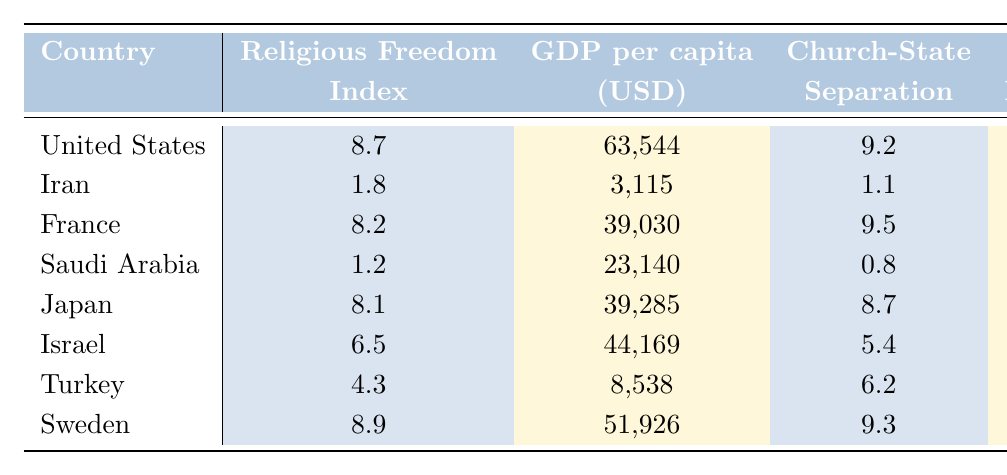What is the Religious Freedom Index of the United States? The Religious Freedom Index for the United States is directly indicated in the table as 8.7.
Answer: 8.7 Which country has the highest GDP per capita? From the GDP per capita column, Sweden has the highest value at 51,926 USD.
Answer: Sweden Is there a significant difference in the Separation of Church and State Score between Iran and Saudi Arabia? The Separation of Church and State Score for Iran is 1.1, while for Saudi Arabia it is 0.8. The difference is 1.1 - 0.8 = 0.3, which is indeed significant considering both are quite low.
Answer: Yes What is the average Government Restrictions Index for the countries listed? The values are 2.7, 8.3, 3.2, 8.4, 1.8, 4.7, 6.9, 1.9. Adding these gives a total of 37.9, and there are 8 countries, so the average is 37.9 / 8 = 4.7375, which rounds to 4.74.
Answer: 4.74 Which country has the lowest percentage of religious minorities? The table shows that Turkey has the lowest percentage of religious minorities at 0.4%.
Answer: Turkey Are the Religious Freedom Index and GDP per capita positively correlated in this data set? By examining the two columns, we can see that higher GDP per capita generally coincides with higher Religious Freedom Index scores—countries with low GDP like Iran and Saudi Arabia also have low indices, while the U.S. and Sweden, which have high GDPs, have high indices.
Answer: Yes Which two countries have the closest GDP per capita values? Looking at the GDP per capita values, Japan (39,285 USD) and France (39,030 USD) are closest, with a difference of 255 USD.
Answer: Japan and France What is the total percentage of religious minorities in countries with a state religion? The countries with state religions are Iran, Saudi Arabia, and Israel. Their percentages are 2%, 5%, and 24%, respectively. Adding these up gives 2 + 5 + 24 = 31%.
Answer: 31% Which country has a better Religious Freedom Index than Japan? Japan has a Religious Freedom Index of 8.1. The countries with a higher index are the United States (8.7), France (8.2), and Sweden (8.9).
Answer: United States, France, Sweden Is the Government Restrictions Index lower in the United States compared to Turkey? The Government Restrictions Index for the United States is 2.7, while for Turkey, it is 6.9. Since 2.7 is less than 6.9, the statement is true.
Answer: Yes 